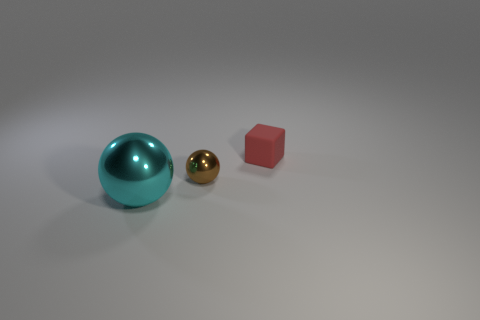Are the cyan ball and the tiny brown ball made of the same material?
Your response must be concise. Yes. There is a object that is both to the left of the red block and to the right of the cyan thing; what color is it?
Provide a succinct answer. Brown. There is a thing that is right of the tiny thing that is in front of the tiny cube; what size is it?
Offer a very short reply. Small. What shape is the brown thing that is the same size as the block?
Give a very brief answer. Sphere. What is the color of the other tiny sphere that is the same material as the cyan ball?
Your response must be concise. Brown. Are there any other things that have the same shape as the cyan metallic object?
Your answer should be very brief. Yes. What is the material of the tiny thing in front of the tiny matte object?
Make the answer very short. Metal. Does the small object left of the tiny red object have the same material as the tiny red cube?
Make the answer very short. No. How many objects are cyan objects or spheres that are behind the cyan thing?
Your response must be concise. 2. The other object that is the same shape as the brown object is what size?
Provide a succinct answer. Large. 